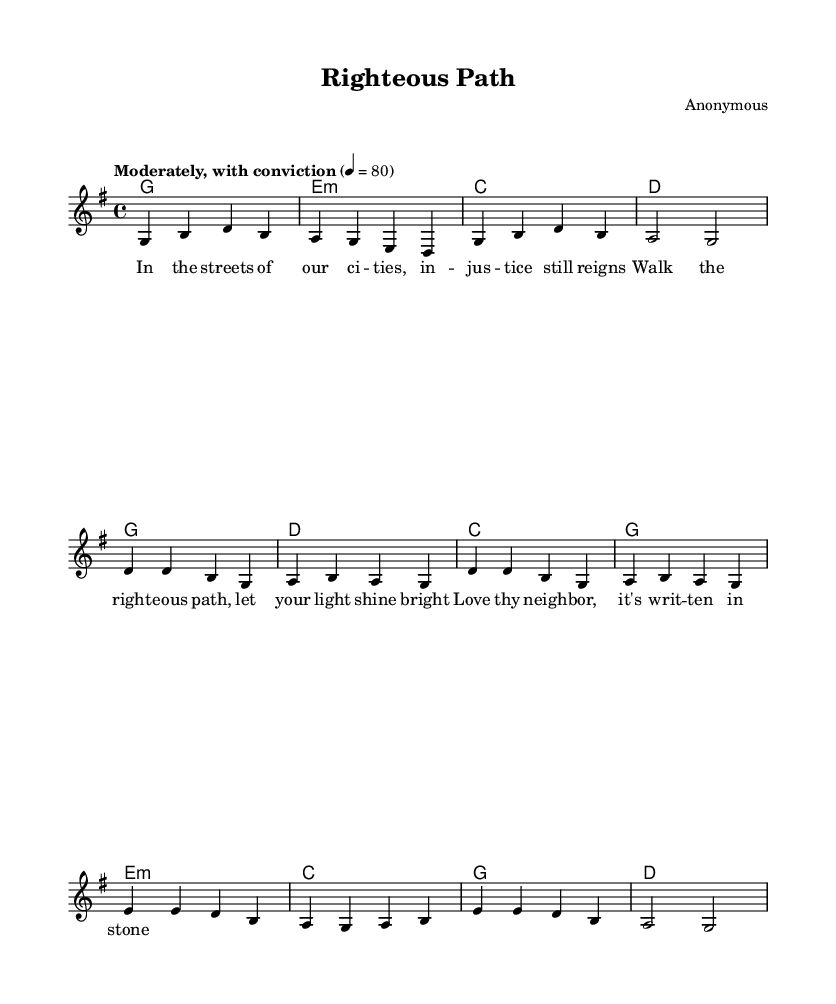What is the key signature of this music? The key signature indicated in the music is G major, which has one sharp (F#). It can be identified at the beginning of the staff where the sharp symbol is placed on the F line.
Answer: G major What is the time signature of this music? The time signature is located at the beginning of the score and indicates the number of beats per measure. Here, it shows 4 beats per measure, which is standardly notated as 4/4.
Answer: 4/4 What is the tempo marking of this piece? The tempo marking is stated above the staff, where "Moderately, with conviction" indicates the style of performance. Additionally, the number 80 indicates the beats per minute, which guides the performer on how fast to play.
Answer: Moderately, with conviction How many measures are in the first verse? The first verse consists of four measures, which can be counted by observing the vertical bar lines that separate the measures in the music. Each group of notes before a bar line signifies one measure.
Answer: Four What is the harmonic structure used in this piece? The harmonic structure is provided through chord symbols which are shown above the vocal line. The chords follow a progression of G, E minor, C, and D within the first two sections, establishing a folk style along with reinforcing the song's religious message.
Answer: G, E minor, C, D Which lyric corresponds with the bridge section? To find the corresponding lyric for the bridge section, one must cross-reference the lyrics with the musical notation. The bridge is recognized by its unique melody and follows the primary lyrical sequence, where the pertinent lyrics begin with "In the streets of our cities" leading into the subsequent lines directed to social justice themes.
Answer: In the streets of our cities 